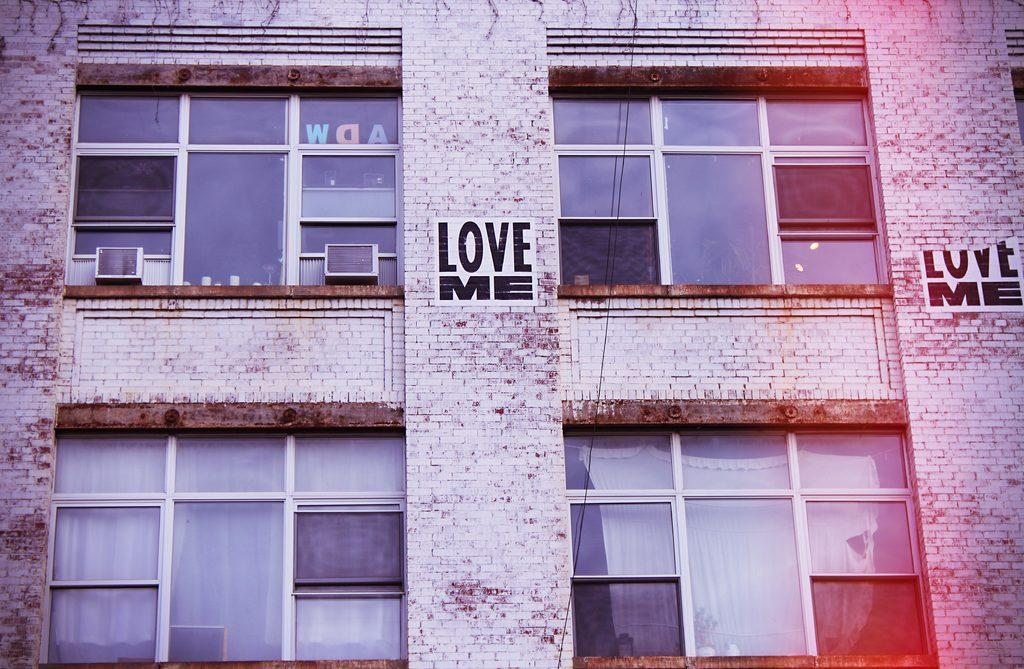What type of structure is present in the image? There is a building in the image. What feature can be observed on the building? The building has glass windows. What decorative elements are present on the walls of the building? There are posters on the walls of the building. What can be seen through the windows of the building? Curtains are visible through the windows. How does the building contribute to the wealth of the community in the image? The image does not provide any information about the building's impact on the community's wealth. --- Facts: 1. There is a person sitting on a chair in the image. 2. The person is holding a book. 3. The book has a blue cover. 4. There is a table next to the chair. 5. A lamp is on the table. Absurd Topics: dance, ocean, mountain Conversation: What is the person in the image doing? The person is sitting on a chair in the image. What object is the person holding? The person is holding a book. What color is the book's cover? The book has a blue cover. What piece of furniture is next to the chair? There is a table next to the chair. What is on the table? A lamp is on the table. Reasoning: Let's think step by step in order to produce the conversation. We start by identifying the main subject in the image, which is the person sitting on a chair. Then, we expand the conversation to include the object the person is holding (a book) and its specific characteristic (a blue cover). Finally, we mention the table and lamp, which provide additional context about the setting. Absurd Question/Answer: Can you describe the ocean view from the chair in the image? There is no ocean view present in the image; it only shows a person sitting on a chair, holding a book, and a table with a lamp. 